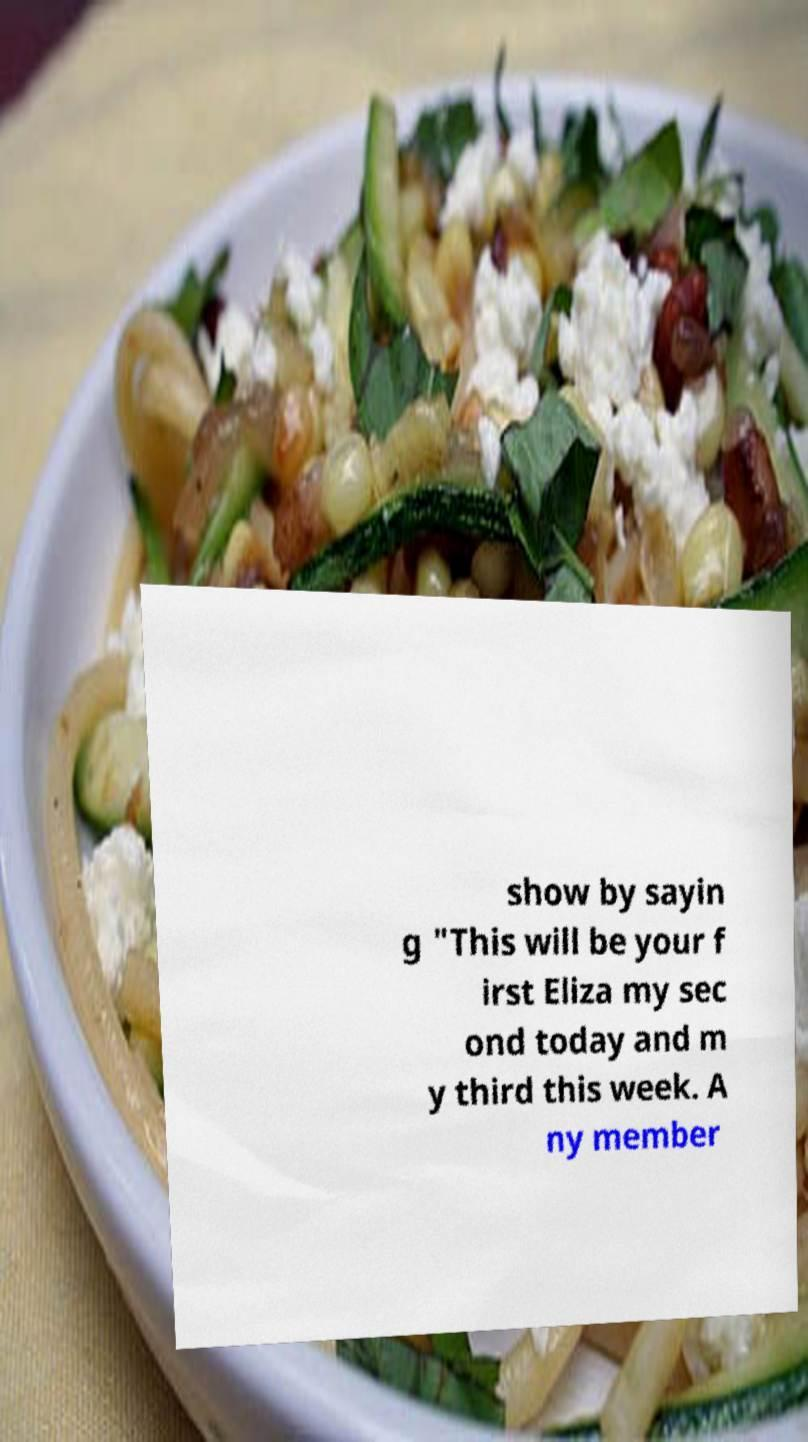Please identify and transcribe the text found in this image. show by sayin g "This will be your f irst Eliza my sec ond today and m y third this week. A ny member 